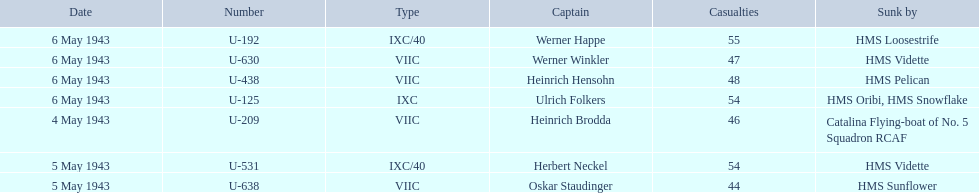Who were the captains in the ons 5 convoy? Heinrich Brodda, Oskar Staudinger, Herbert Neckel, Werner Happe, Ulrich Folkers, Werner Winkler, Heinrich Hensohn. Give me the full table as a dictionary. {'header': ['Date', 'Number', 'Type', 'Captain', 'Casualties', 'Sunk by'], 'rows': [['6 May 1943', 'U-192', 'IXC/40', 'Werner Happe', '55', 'HMS Loosestrife'], ['6 May 1943', 'U-630', 'VIIC', 'Werner Winkler', '47', 'HMS Vidette'], ['6 May 1943', 'U-438', 'VIIC', 'Heinrich Hensohn', '48', 'HMS Pelican'], ['6 May 1943', 'U-125', 'IXC', 'Ulrich Folkers', '54', 'HMS Oribi, HMS Snowflake'], ['4 May 1943', 'U-209', 'VIIC', 'Heinrich Brodda', '46', 'Catalina Flying-boat of No. 5 Squadron RCAF'], ['5 May 1943', 'U-531', 'IXC/40', 'Herbert Neckel', '54', 'HMS Vidette'], ['5 May 1943', 'U-638', 'VIIC', 'Oskar Staudinger', '44', 'HMS Sunflower']]} Which ones lost their u-boat on may 5? Oskar Staudinger, Herbert Neckel. Of those, which one is not oskar staudinger? Herbert Neckel. 